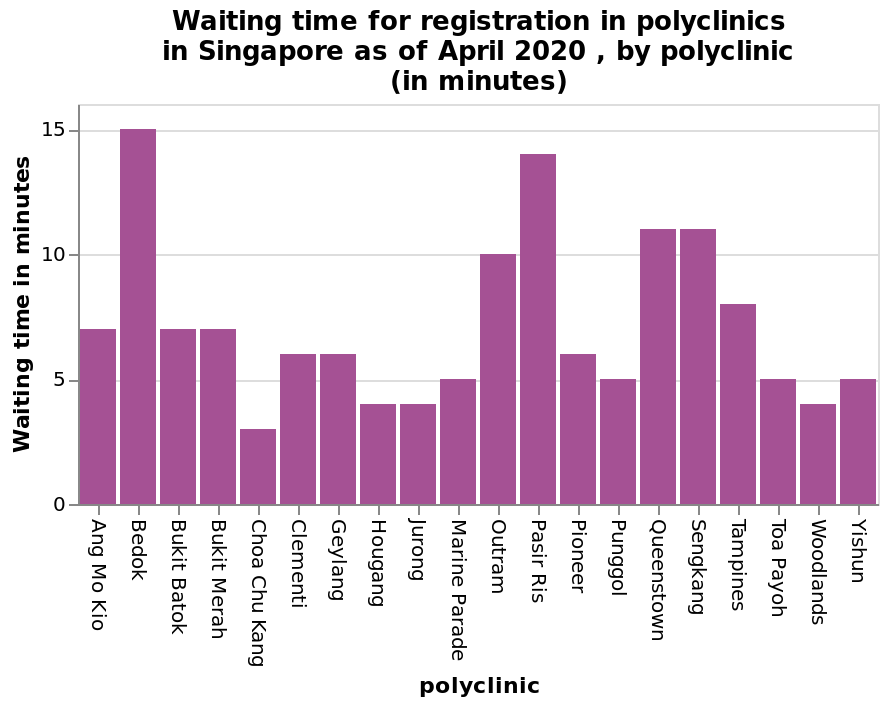<image>
What was the range of waiting times? The range of waiting times was 3 to 15 minutes. What was the minimum waiting time? The minimum waiting time was 3 minutes. please summary the statistics and relations of the chart THE MAXIMUM WAITING TIME WAS 15 MINUTES . THE MINIMUM WAITING TIME WAS 3 MINUTES. Was the maximum waiting time less than 10 minutes? No, the maximum waiting time was 15 minutes. 